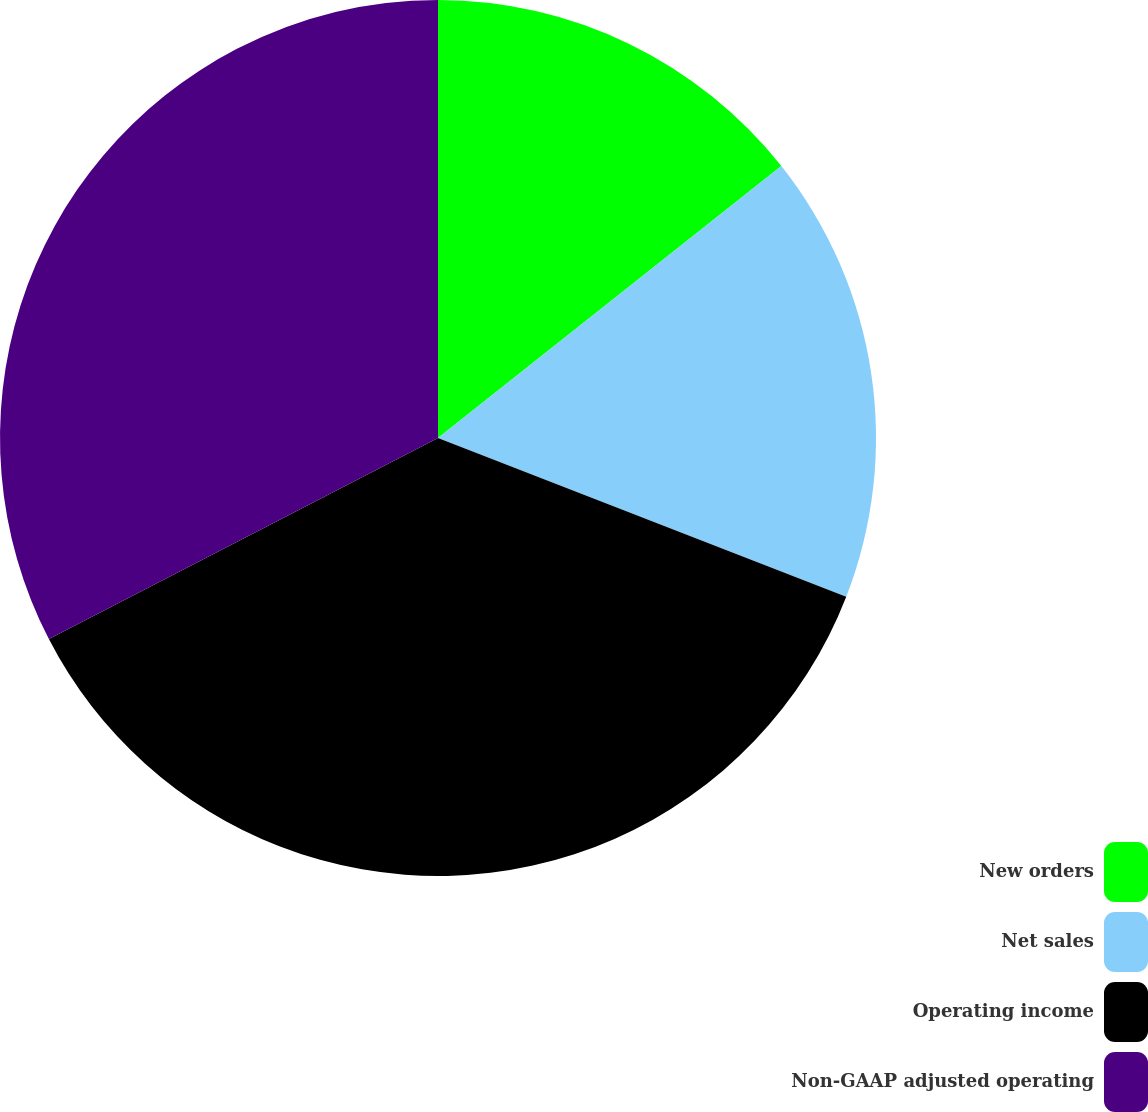<chart> <loc_0><loc_0><loc_500><loc_500><pie_chart><fcel>New orders<fcel>Net sales<fcel>Operating income<fcel>Non-GAAP adjusted operating<nl><fcel>14.34%<fcel>16.56%<fcel>36.51%<fcel>32.59%<nl></chart> 